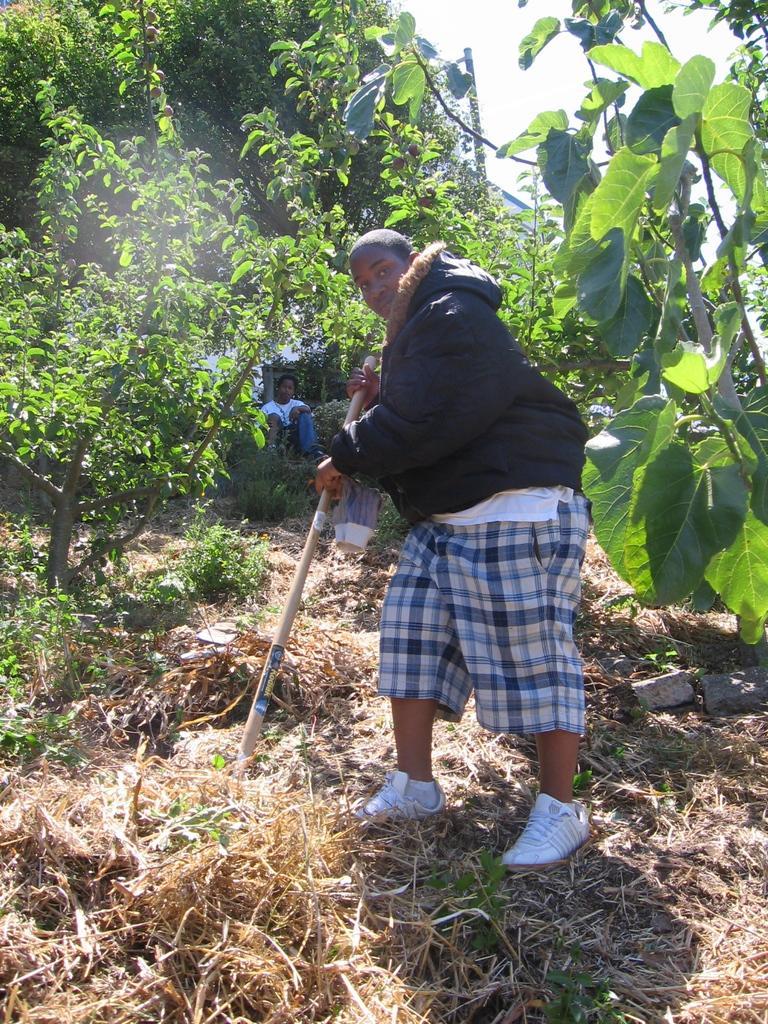How would you summarize this image in a sentence or two? In this picture there is a person standing and holding the object and there is a person sitting at the back and there is a building and there are trees. At the top there is sky. At the bottom there is grass. 